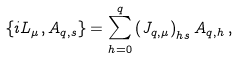<formula> <loc_0><loc_0><loc_500><loc_500>\{ i L _ { \mu } , A _ { q , s } \} = \sum _ { h = 0 } ^ { q } \left ( J _ { q , \mu } \right ) _ { h s } A _ { q , h } \, ,</formula> 